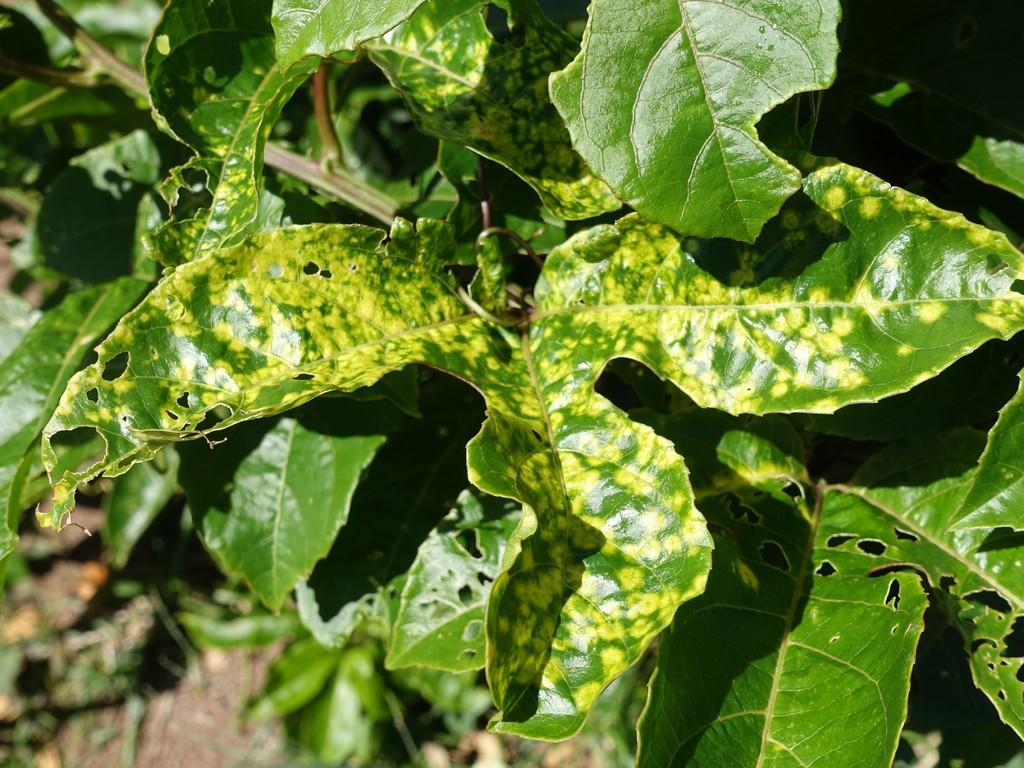What type of plant material is visible in the image? There are leaves on stems in the image. What decision does the page make in the image? There is no page or decision present in the image; it only features leaves on stems. 